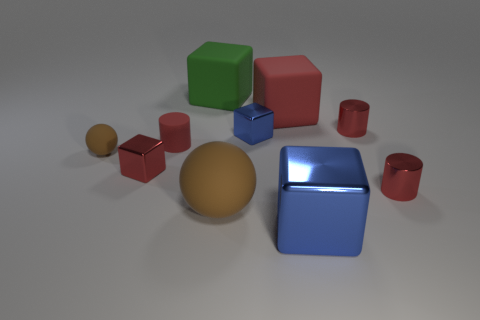Subtract all red cylinders. How many were subtracted if there are1red cylinders left? 2 Subtract all green cubes. How many cubes are left? 4 Subtract all red rubber blocks. How many blocks are left? 4 Subtract all cyan blocks. Subtract all red spheres. How many blocks are left? 5 Subtract all cylinders. How many objects are left? 7 Subtract 0 cyan cylinders. How many objects are left? 10 Subtract all big metal objects. Subtract all large rubber things. How many objects are left? 6 Add 1 rubber balls. How many rubber balls are left? 3 Add 8 small blue metal cubes. How many small blue metal cubes exist? 9 